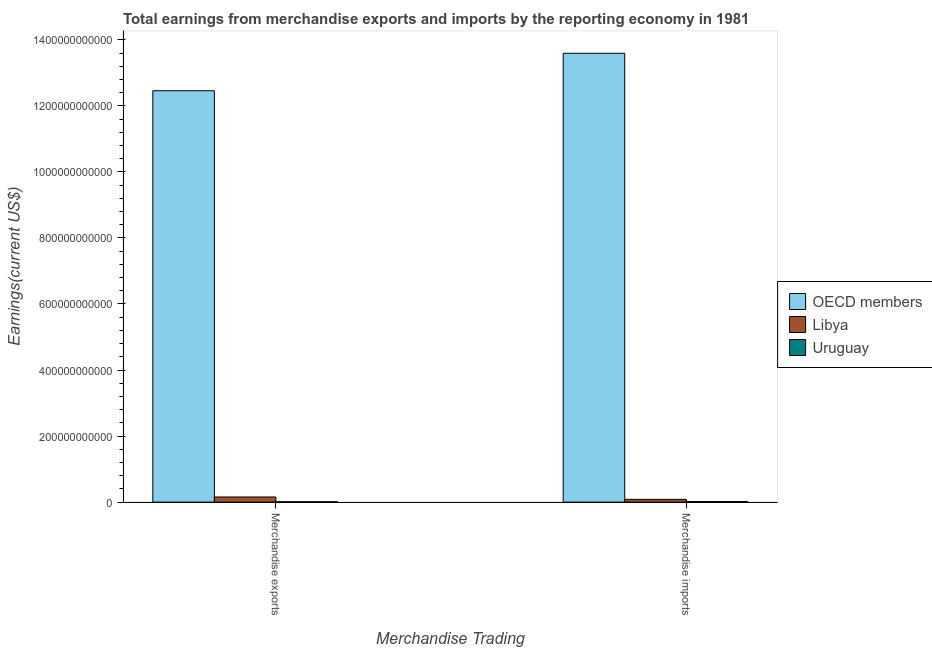How many different coloured bars are there?
Make the answer very short. 3. Are the number of bars per tick equal to the number of legend labels?
Provide a succinct answer. Yes. Are the number of bars on each tick of the X-axis equal?
Provide a succinct answer. Yes. How many bars are there on the 1st tick from the left?
Ensure brevity in your answer.  3. How many bars are there on the 2nd tick from the right?
Ensure brevity in your answer.  3. What is the label of the 2nd group of bars from the left?
Your response must be concise. Merchandise imports. What is the earnings from merchandise exports in OECD members?
Ensure brevity in your answer.  1.25e+12. Across all countries, what is the maximum earnings from merchandise exports?
Provide a short and direct response. 1.25e+12. Across all countries, what is the minimum earnings from merchandise exports?
Offer a terse response. 1.18e+09. In which country was the earnings from merchandise exports maximum?
Your answer should be very brief. OECD members. In which country was the earnings from merchandise imports minimum?
Provide a succinct answer. Uruguay. What is the total earnings from merchandise exports in the graph?
Offer a very short reply. 1.26e+12. What is the difference between the earnings from merchandise exports in Uruguay and that in OECD members?
Offer a terse response. -1.24e+12. What is the difference between the earnings from merchandise exports in Libya and the earnings from merchandise imports in OECD members?
Provide a short and direct response. -1.34e+12. What is the average earnings from merchandise exports per country?
Provide a succinct answer. 4.21e+11. What is the difference between the earnings from merchandise imports and earnings from merchandise exports in OECD members?
Keep it short and to the point. 1.13e+11. What is the ratio of the earnings from merchandise imports in Libya to that in OECD members?
Keep it short and to the point. 0.01. Is the earnings from merchandise imports in Uruguay less than that in Libya?
Your answer should be very brief. Yes. In how many countries, is the earnings from merchandise exports greater than the average earnings from merchandise exports taken over all countries?
Keep it short and to the point. 1. What does the 2nd bar from the right in Merchandise imports represents?
Keep it short and to the point. Libya. How many bars are there?
Your answer should be compact. 6. How many countries are there in the graph?
Your answer should be very brief. 3. What is the difference between two consecutive major ticks on the Y-axis?
Provide a succinct answer. 2.00e+11. How many legend labels are there?
Provide a succinct answer. 3. What is the title of the graph?
Provide a succinct answer. Total earnings from merchandise exports and imports by the reporting economy in 1981. What is the label or title of the X-axis?
Give a very brief answer. Merchandise Trading. What is the label or title of the Y-axis?
Make the answer very short. Earnings(current US$). What is the Earnings(current US$) in OECD members in Merchandise exports?
Make the answer very short. 1.25e+12. What is the Earnings(current US$) of Libya in Merchandise exports?
Give a very brief answer. 1.56e+1. What is the Earnings(current US$) in Uruguay in Merchandise exports?
Provide a short and direct response. 1.18e+09. What is the Earnings(current US$) in OECD members in Merchandise imports?
Make the answer very short. 1.36e+12. What is the Earnings(current US$) of Libya in Merchandise imports?
Keep it short and to the point. 8.38e+09. What is the Earnings(current US$) in Uruguay in Merchandise imports?
Your answer should be very brief. 1.63e+09. Across all Merchandise Trading, what is the maximum Earnings(current US$) in OECD members?
Keep it short and to the point. 1.36e+12. Across all Merchandise Trading, what is the maximum Earnings(current US$) of Libya?
Make the answer very short. 1.56e+1. Across all Merchandise Trading, what is the maximum Earnings(current US$) in Uruguay?
Ensure brevity in your answer.  1.63e+09. Across all Merchandise Trading, what is the minimum Earnings(current US$) of OECD members?
Give a very brief answer. 1.25e+12. Across all Merchandise Trading, what is the minimum Earnings(current US$) in Libya?
Give a very brief answer. 8.38e+09. Across all Merchandise Trading, what is the minimum Earnings(current US$) in Uruguay?
Your answer should be very brief. 1.18e+09. What is the total Earnings(current US$) in OECD members in the graph?
Offer a terse response. 2.61e+12. What is the total Earnings(current US$) in Libya in the graph?
Provide a succinct answer. 2.40e+1. What is the total Earnings(current US$) of Uruguay in the graph?
Your response must be concise. 2.81e+09. What is the difference between the Earnings(current US$) of OECD members in Merchandise exports and that in Merchandise imports?
Provide a succinct answer. -1.13e+11. What is the difference between the Earnings(current US$) of Libya in Merchandise exports and that in Merchandise imports?
Give a very brief answer. 7.19e+09. What is the difference between the Earnings(current US$) of Uruguay in Merchandise exports and that in Merchandise imports?
Your answer should be very brief. -4.44e+08. What is the difference between the Earnings(current US$) of OECD members in Merchandise exports and the Earnings(current US$) of Libya in Merchandise imports?
Offer a terse response. 1.24e+12. What is the difference between the Earnings(current US$) of OECD members in Merchandise exports and the Earnings(current US$) of Uruguay in Merchandise imports?
Offer a very short reply. 1.24e+12. What is the difference between the Earnings(current US$) in Libya in Merchandise exports and the Earnings(current US$) in Uruguay in Merchandise imports?
Offer a very short reply. 1.39e+1. What is the average Earnings(current US$) in OECD members per Merchandise Trading?
Provide a short and direct response. 1.30e+12. What is the average Earnings(current US$) of Libya per Merchandise Trading?
Provide a succinct answer. 1.20e+1. What is the average Earnings(current US$) in Uruguay per Merchandise Trading?
Your answer should be compact. 1.40e+09. What is the difference between the Earnings(current US$) in OECD members and Earnings(current US$) in Libya in Merchandise exports?
Ensure brevity in your answer.  1.23e+12. What is the difference between the Earnings(current US$) of OECD members and Earnings(current US$) of Uruguay in Merchandise exports?
Offer a very short reply. 1.24e+12. What is the difference between the Earnings(current US$) in Libya and Earnings(current US$) in Uruguay in Merchandise exports?
Provide a succinct answer. 1.44e+1. What is the difference between the Earnings(current US$) in OECD members and Earnings(current US$) in Libya in Merchandise imports?
Ensure brevity in your answer.  1.35e+12. What is the difference between the Earnings(current US$) in OECD members and Earnings(current US$) in Uruguay in Merchandise imports?
Your answer should be very brief. 1.36e+12. What is the difference between the Earnings(current US$) of Libya and Earnings(current US$) of Uruguay in Merchandise imports?
Provide a succinct answer. 6.76e+09. What is the ratio of the Earnings(current US$) in OECD members in Merchandise exports to that in Merchandise imports?
Give a very brief answer. 0.92. What is the ratio of the Earnings(current US$) of Libya in Merchandise exports to that in Merchandise imports?
Ensure brevity in your answer.  1.86. What is the ratio of the Earnings(current US$) in Uruguay in Merchandise exports to that in Merchandise imports?
Your answer should be compact. 0.73. What is the difference between the highest and the second highest Earnings(current US$) of OECD members?
Your response must be concise. 1.13e+11. What is the difference between the highest and the second highest Earnings(current US$) of Libya?
Provide a succinct answer. 7.19e+09. What is the difference between the highest and the second highest Earnings(current US$) of Uruguay?
Ensure brevity in your answer.  4.44e+08. What is the difference between the highest and the lowest Earnings(current US$) of OECD members?
Make the answer very short. 1.13e+11. What is the difference between the highest and the lowest Earnings(current US$) in Libya?
Offer a terse response. 7.19e+09. What is the difference between the highest and the lowest Earnings(current US$) in Uruguay?
Give a very brief answer. 4.44e+08. 